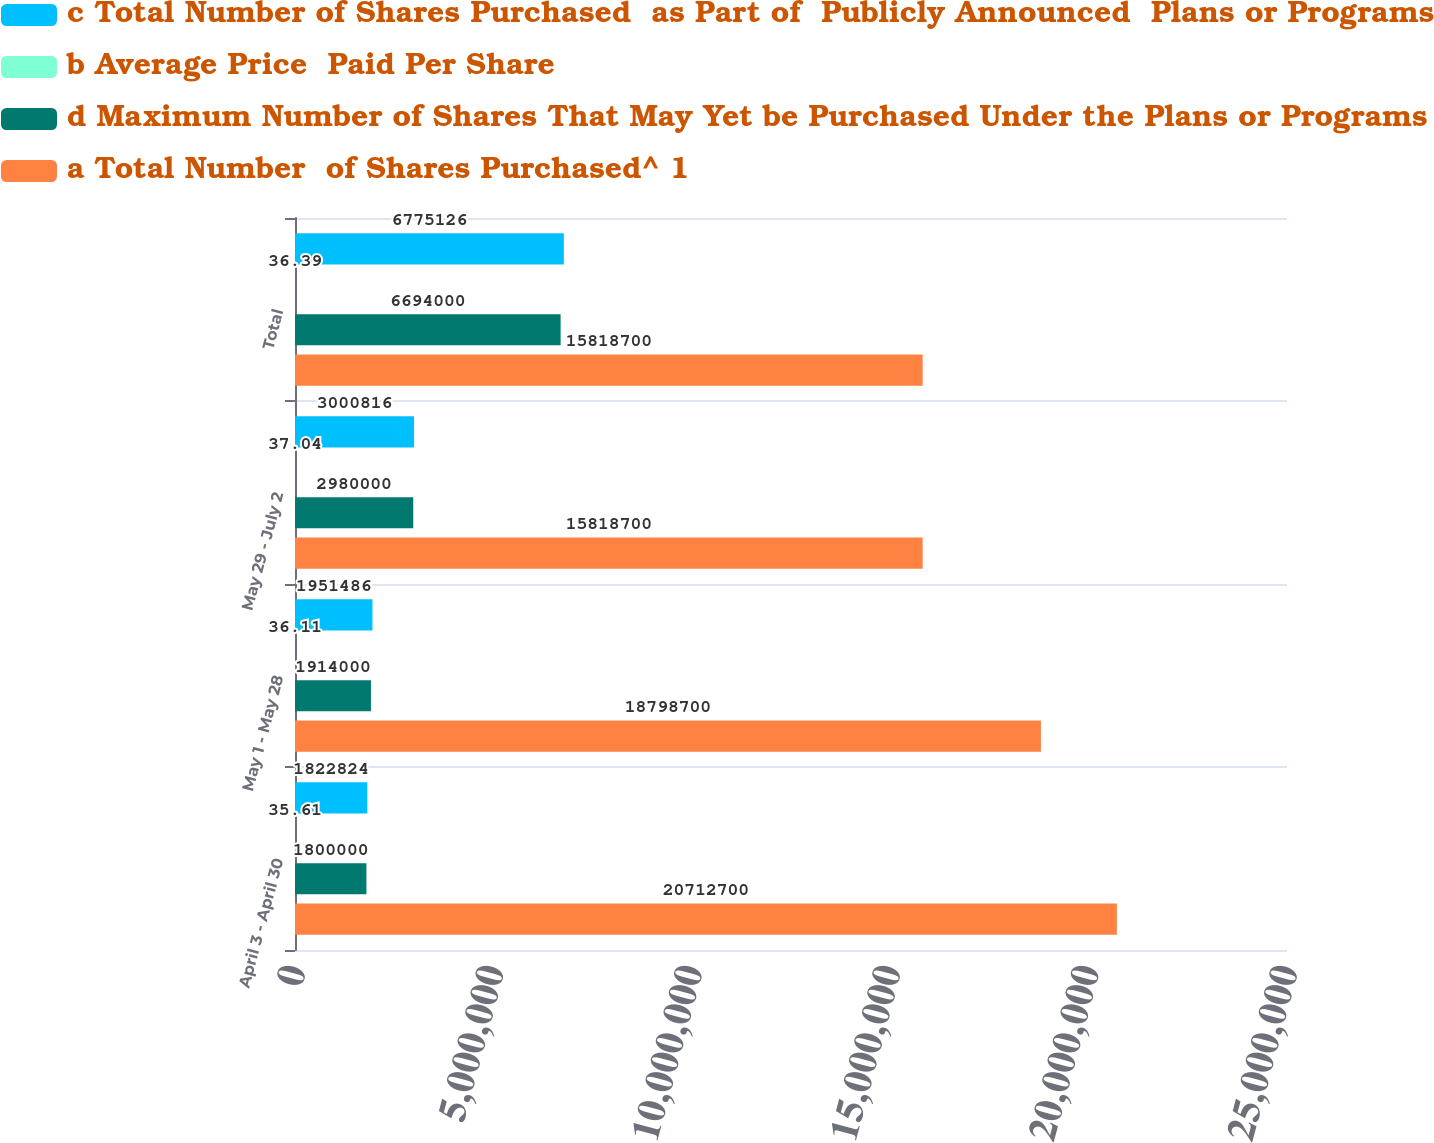Convert chart to OTSL. <chart><loc_0><loc_0><loc_500><loc_500><stacked_bar_chart><ecel><fcel>April 3 - April 30<fcel>May 1 - May 28<fcel>May 29 - July 2<fcel>Total<nl><fcel>c Total Number of Shares Purchased  as Part of  Publicly Announced  Plans or Programs<fcel>1.82282e+06<fcel>1.95149e+06<fcel>3.00082e+06<fcel>6.77513e+06<nl><fcel>b Average Price  Paid Per Share<fcel>35.61<fcel>36.11<fcel>37.04<fcel>36.39<nl><fcel>d Maximum Number of Shares That May Yet be Purchased Under the Plans or Programs<fcel>1.8e+06<fcel>1.914e+06<fcel>2.98e+06<fcel>6.694e+06<nl><fcel>a Total Number  of Shares Purchased^ 1<fcel>2.07127e+07<fcel>1.87987e+07<fcel>1.58187e+07<fcel>1.58187e+07<nl></chart> 